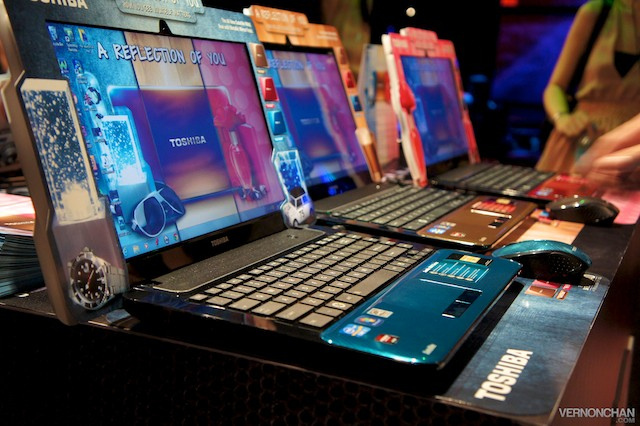Identify the text contained in this image. TOSHIBA A REFLECTION OF you VERNONCHAN TOSHIBA 